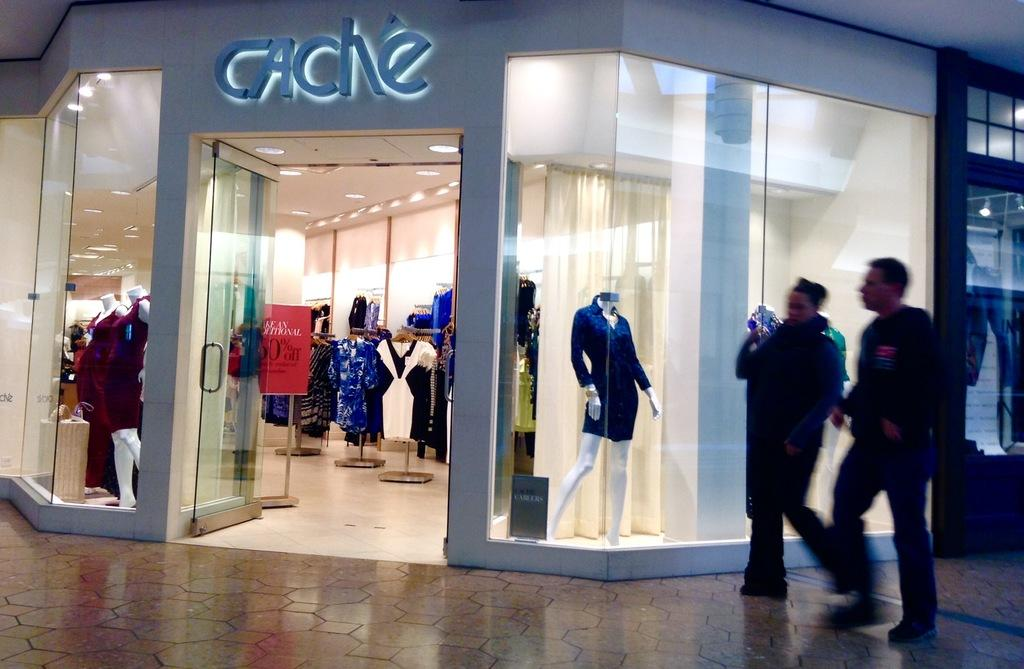What is happening in front of the store in the image? There are people in front of the store in the image. What type of products can be found inside the store? The store contains clothes. Are there any displays or models of clothing in the store? Yes, there are mannequins in the store. How is the store illuminated? The store has lights. What type of advertisement or promotion is present in the store? There is a hoarding in the store. What type of copy is being sold in the store? There is no mention of copy being sold in the store; it contains clothes. What song is being played in the store? There is no information about any song being played in the store. 